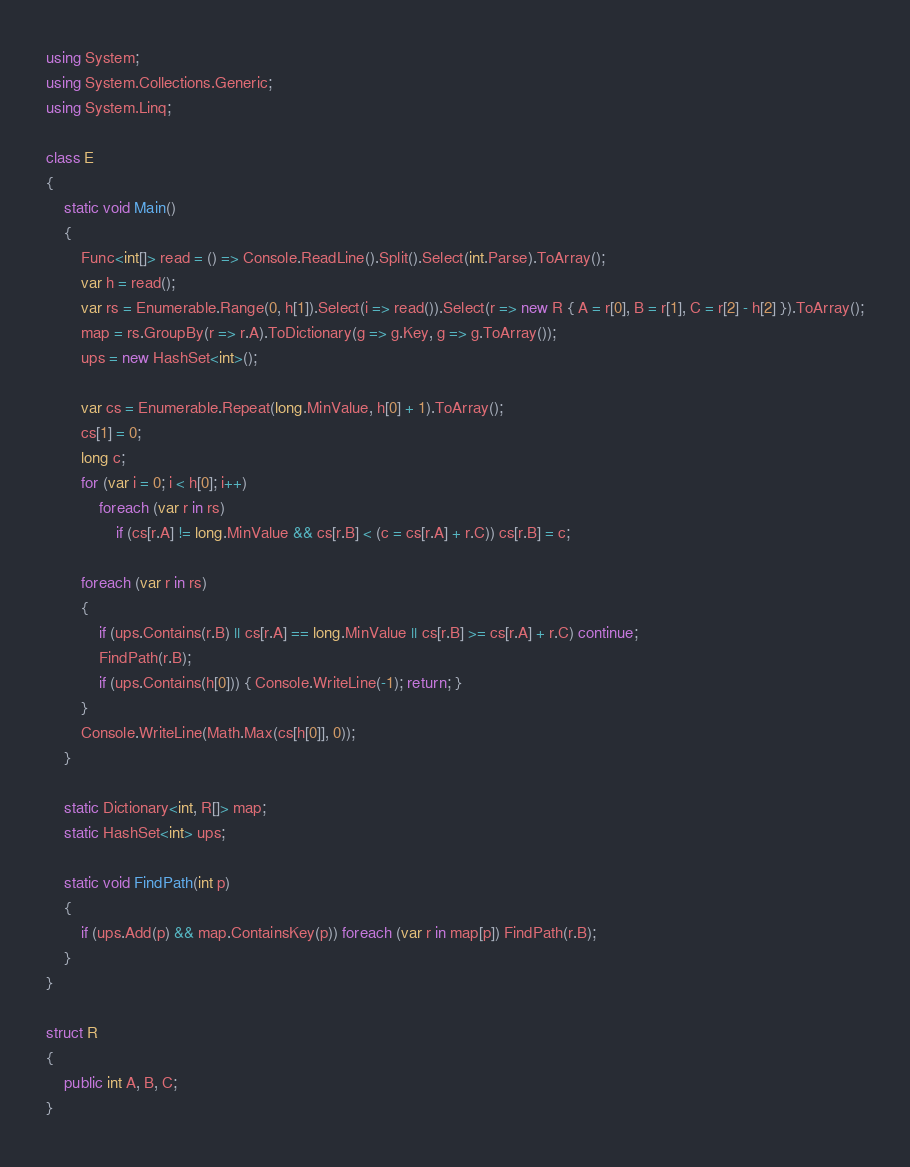<code> <loc_0><loc_0><loc_500><loc_500><_C#_>using System;
using System.Collections.Generic;
using System.Linq;

class E
{
	static void Main()
	{
		Func<int[]> read = () => Console.ReadLine().Split().Select(int.Parse).ToArray();
		var h = read();
		var rs = Enumerable.Range(0, h[1]).Select(i => read()).Select(r => new R { A = r[0], B = r[1], C = r[2] - h[2] }).ToArray();
		map = rs.GroupBy(r => r.A).ToDictionary(g => g.Key, g => g.ToArray());
		ups = new HashSet<int>();

		var cs = Enumerable.Repeat(long.MinValue, h[0] + 1).ToArray();
		cs[1] = 0;
		long c;
		for (var i = 0; i < h[0]; i++)
			foreach (var r in rs)
				if (cs[r.A] != long.MinValue && cs[r.B] < (c = cs[r.A] + r.C)) cs[r.B] = c;

		foreach (var r in rs)
		{
			if (ups.Contains(r.B) || cs[r.A] == long.MinValue || cs[r.B] >= cs[r.A] + r.C) continue;
			FindPath(r.B);
			if (ups.Contains(h[0])) { Console.WriteLine(-1); return; }
		}
		Console.WriteLine(Math.Max(cs[h[0]], 0));
	}

	static Dictionary<int, R[]> map;
	static HashSet<int> ups;

	static void FindPath(int p)
	{
		if (ups.Add(p) && map.ContainsKey(p)) foreach (var r in map[p]) FindPath(r.B);
	}
}

struct R
{
	public int A, B, C;
}
</code> 